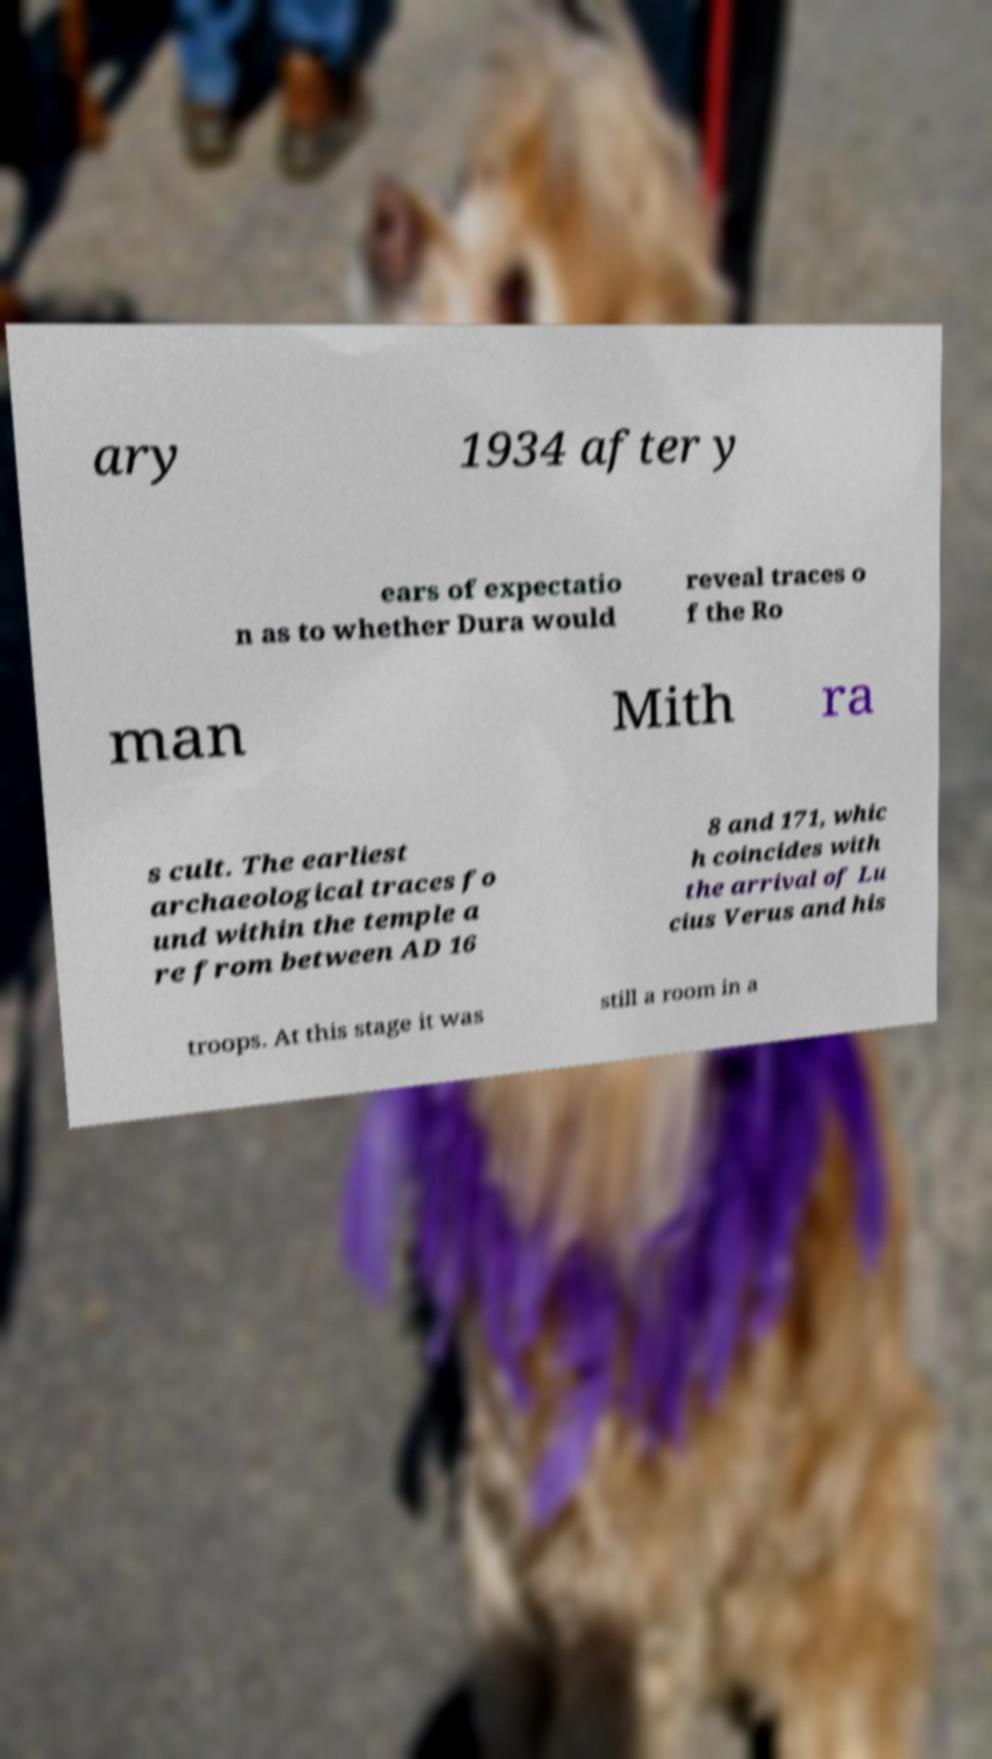Could you assist in decoding the text presented in this image and type it out clearly? ary 1934 after y ears of expectatio n as to whether Dura would reveal traces o f the Ro man Mith ra s cult. The earliest archaeological traces fo und within the temple a re from between AD 16 8 and 171, whic h coincides with the arrival of Lu cius Verus and his troops. At this stage it was still a room in a 